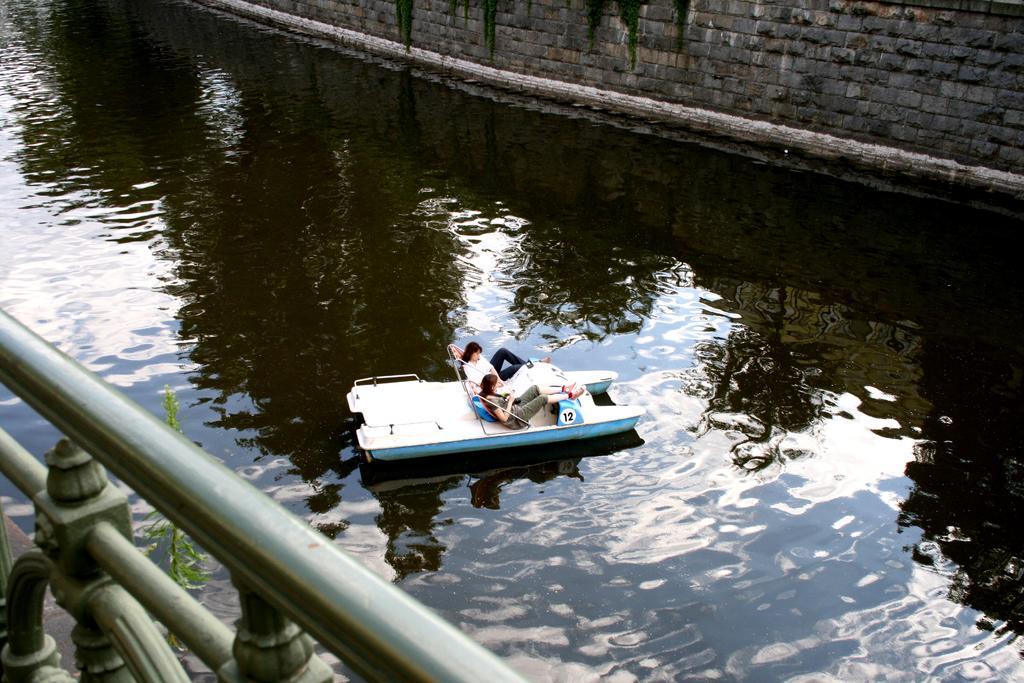How would you summarize this image in a sentence or two? In the center of the image there are two ladies in a boat. there is water. At the background of the image there is a wall. At the left side of the image there is a railing. 